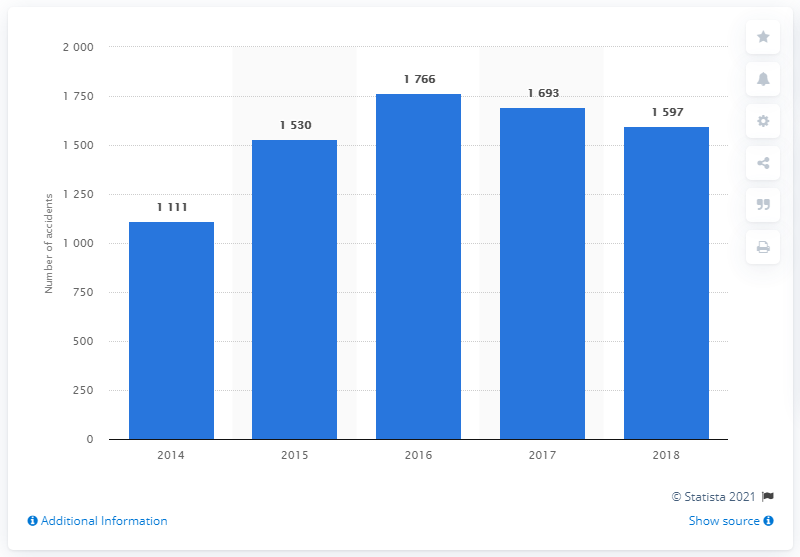Mention a couple of crucial points in this snapshot. The median is 1597. In 2018, a total of 1,597 road accidents occurred in the Indian union territory of Puducherry. The graph depicts approximately 5 years. 